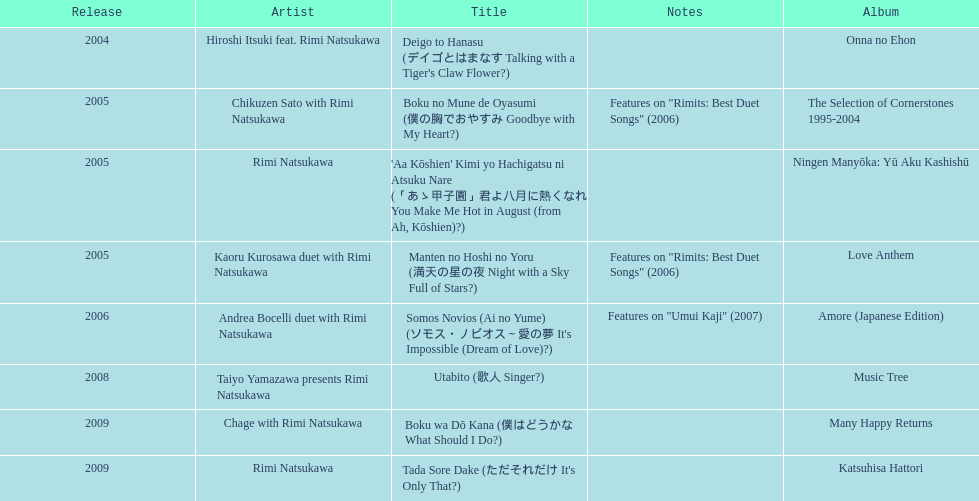How many titles have only one artist? 2. 